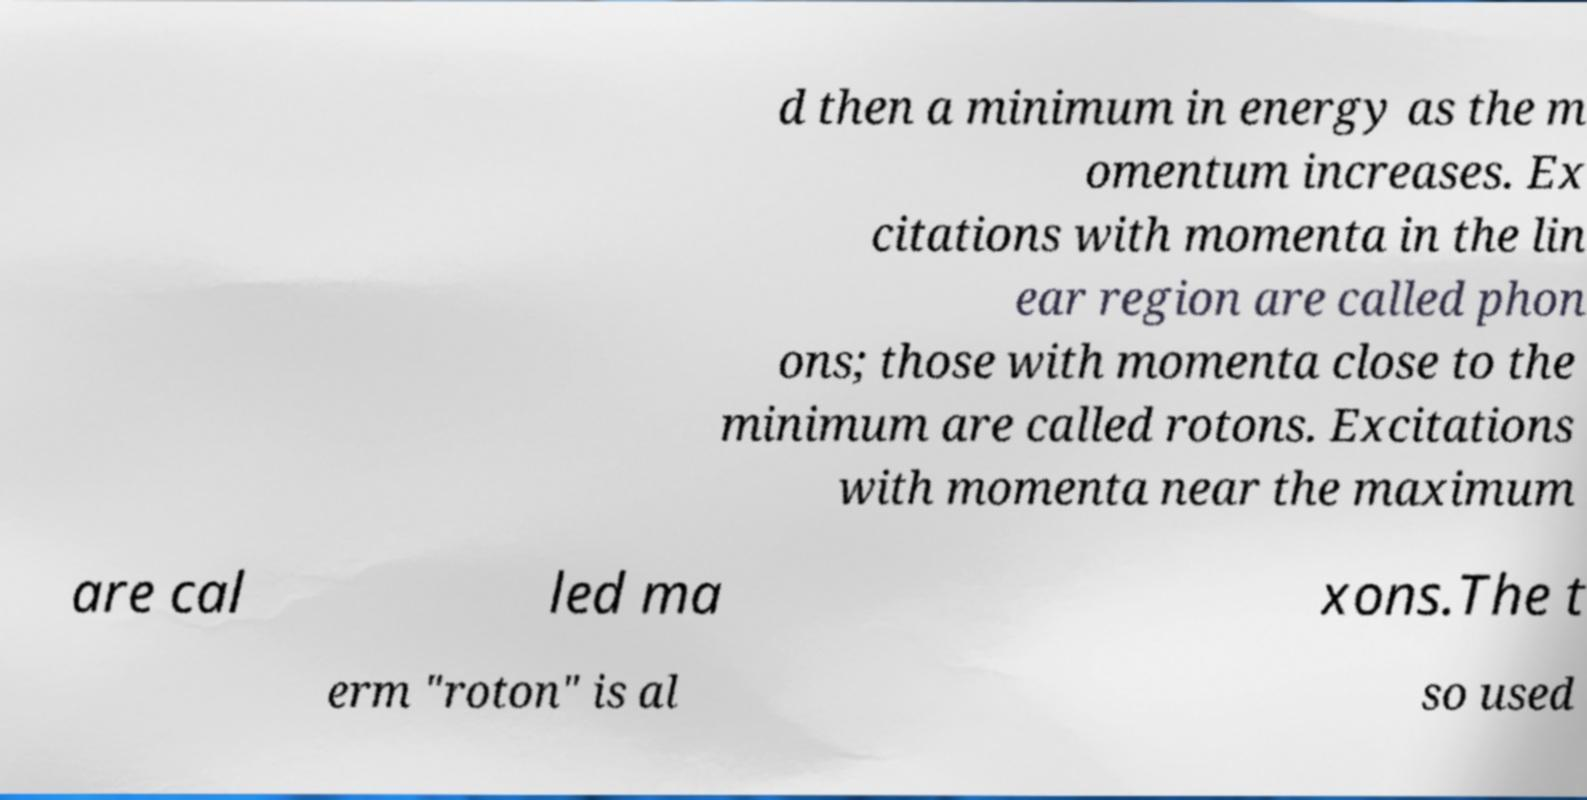There's text embedded in this image that I need extracted. Can you transcribe it verbatim? d then a minimum in energy as the m omentum increases. Ex citations with momenta in the lin ear region are called phon ons; those with momenta close to the minimum are called rotons. Excitations with momenta near the maximum are cal led ma xons.The t erm "roton" is al so used 